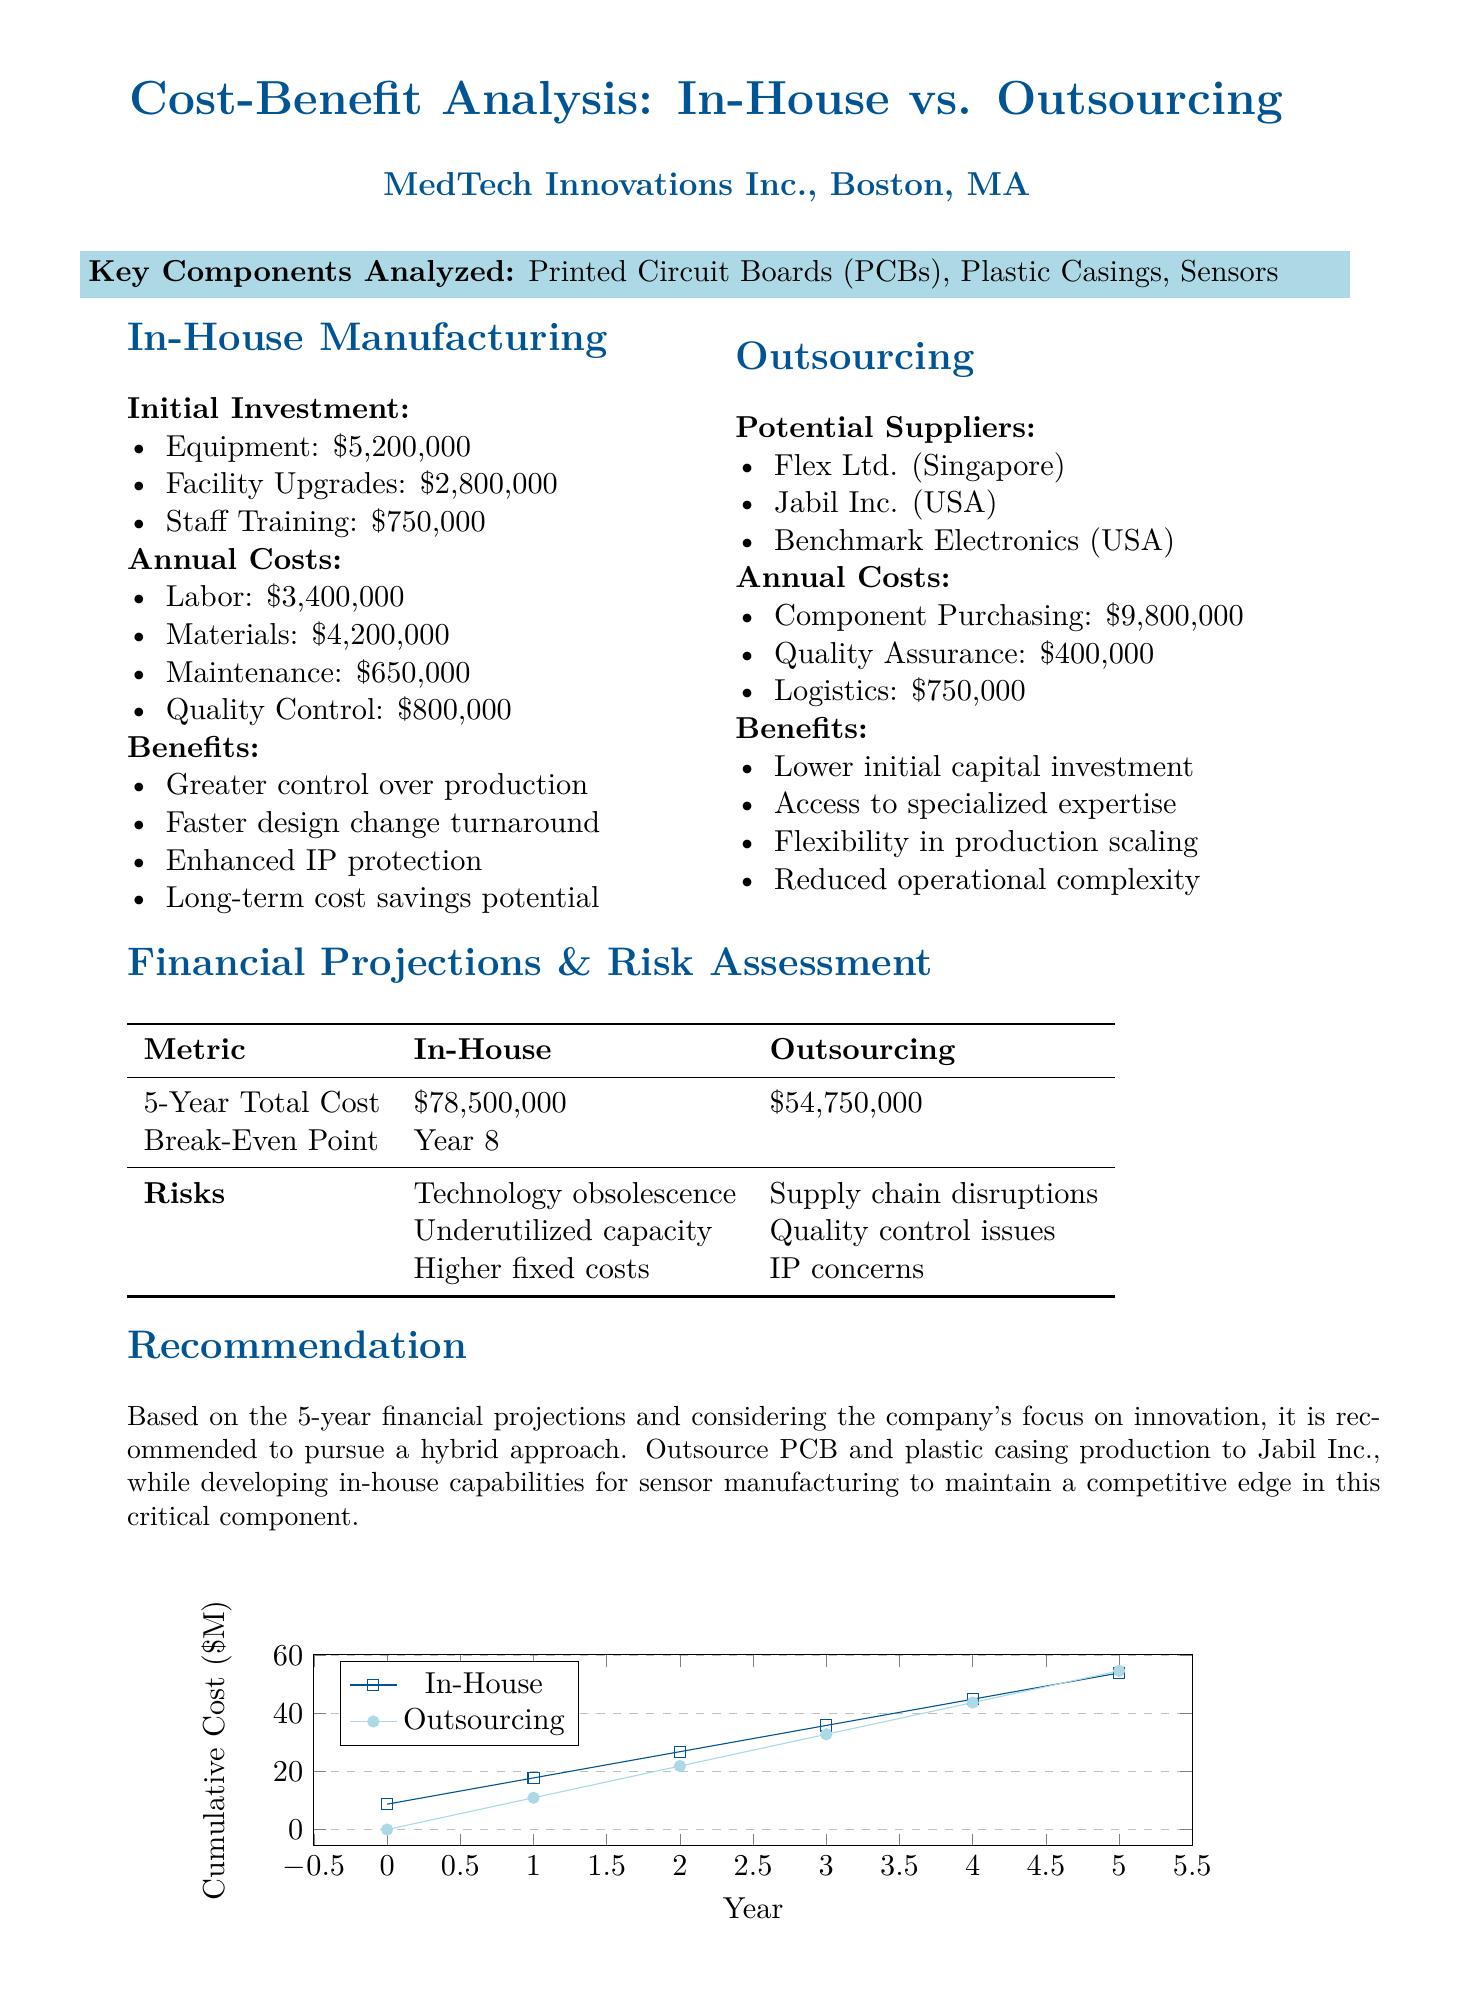What is the initial investment for in-house manufacturing? The initial investment for in-house manufacturing includes equipment, facility upgrades, and staff training totaling $5,200,000 + $2,800,000 + $750,000.
Answer: $8,750,000 What is the annual cost of labor for in-house manufacturing? The document states that the annual cost of labor for in-house manufacturing is $3,400,000.
Answer: $3,400,000 Which suppliers are potential options for outsourcing? The document lists potential suppliers that include Flex Ltd., Jabil Inc., and Benchmark Electronics.
Answer: Flex Ltd., Jabil Inc., Benchmark Electronics What is the total 5-year cost of outsourcing? The total 5-year cost of outsourcing according to the document is $54,750,000.
Answer: $54,750,000 What are the risks associated with in-house manufacturing? The document mentions that risks for in-house manufacturing include technology obsolescence, underutilized capacity, and higher fixed costs.
Answer: Technology obsolescence, underutilized capacity, higher fixed costs What approach is recommended based on the analysis? The document recommends pursuing a hybrid approach to leverage both outsourcing and in-house manufacturing capabilities.
Answer: Hybrid approach What is the break-even point for the in-house manufacturing option? The document states that the break-even point for the in-house manufacturing option is Year 8.
Answer: Year 8 What benefit does in-house manufacturing provide regarding intellectual property? One of the benefits mentioned for in-house manufacturing is enhanced intellectual property protection.
Answer: Enhanced intellectual property protection What standard must the outsourcing supplier meet? The document states that the outsourcing supplier must meet ISO 13485 standards.
Answer: ISO 13485 standards 